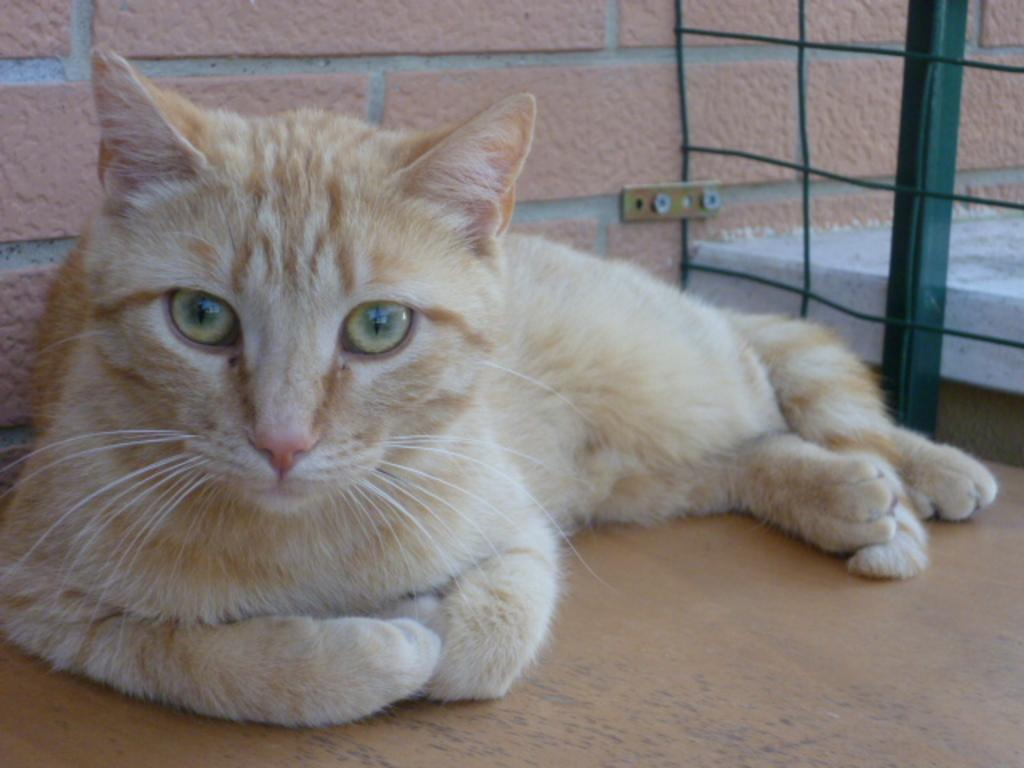What type of animal is in the image? There is a cat in the image. What colors can be seen on the cat? The cat has cream and brown colors. What object can be seen on the right side of the image? There is a green color object that looks like a net fence on the right side of the image. What is visible in the background of the image? There is a wall visible in the background of the image. What type of potato can be seen in the image? There is no potato present in the image; it features a cat with cream and brown colors. What type of flesh can be seen on the cat in the image? The image does not show any flesh on the cat; it only shows the cat's fur. 